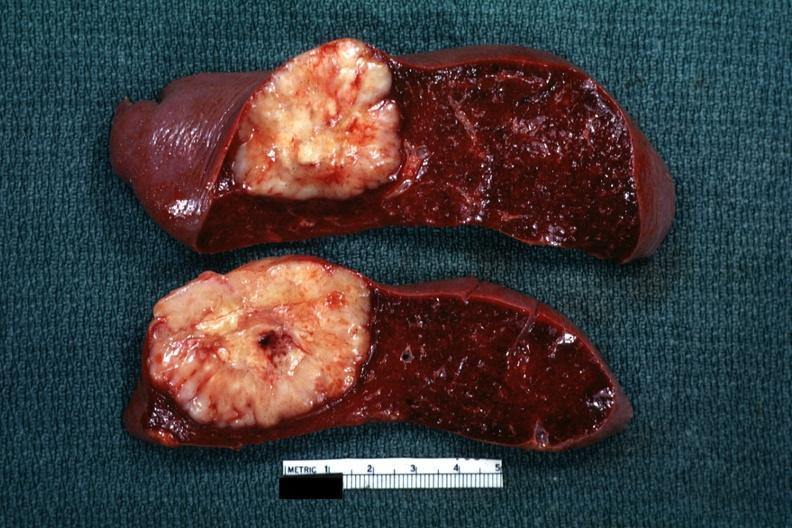what is present?
Answer the question using a single word or phrase. Large cell lymphoma 